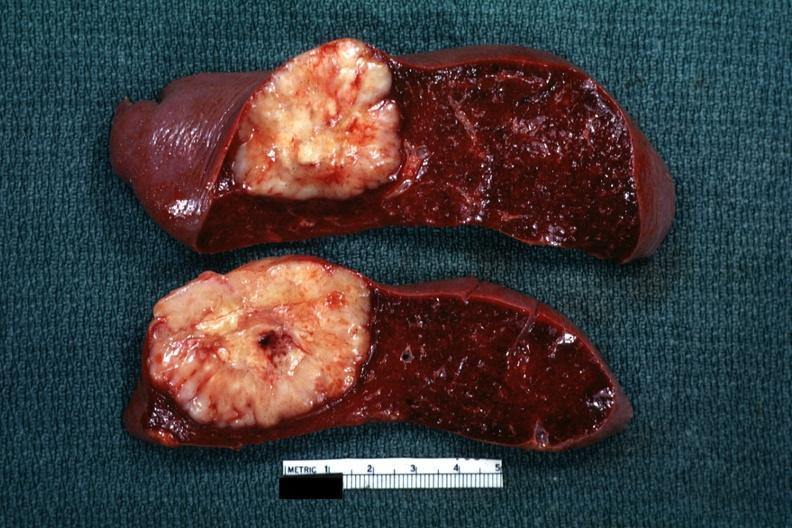what is present?
Answer the question using a single word or phrase. Large cell lymphoma 